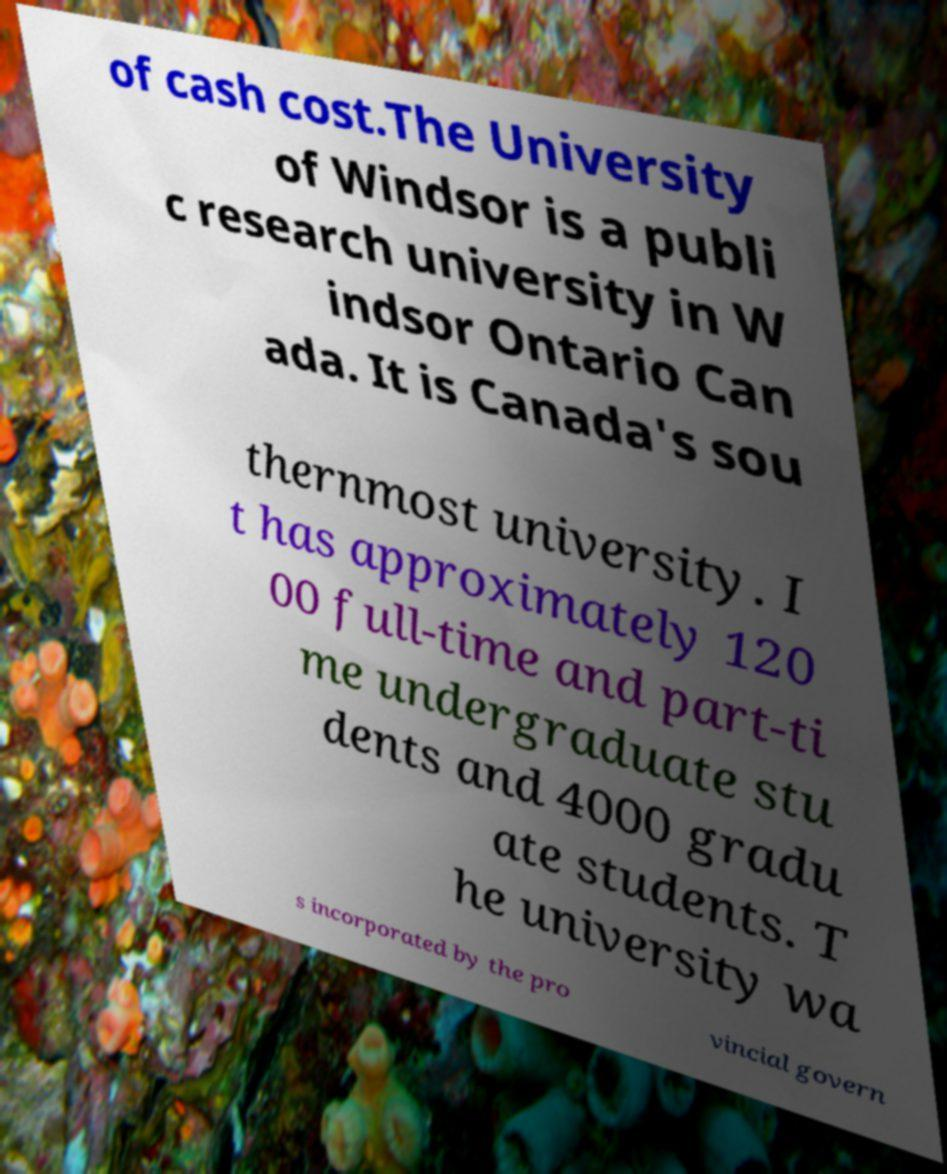Can you read and provide the text displayed in the image?This photo seems to have some interesting text. Can you extract and type it out for me? of cash cost.The University of Windsor is a publi c research university in W indsor Ontario Can ada. It is Canada's sou thernmost university. I t has approximately 120 00 full-time and part-ti me undergraduate stu dents and 4000 gradu ate students. T he university wa s incorporated by the pro vincial govern 